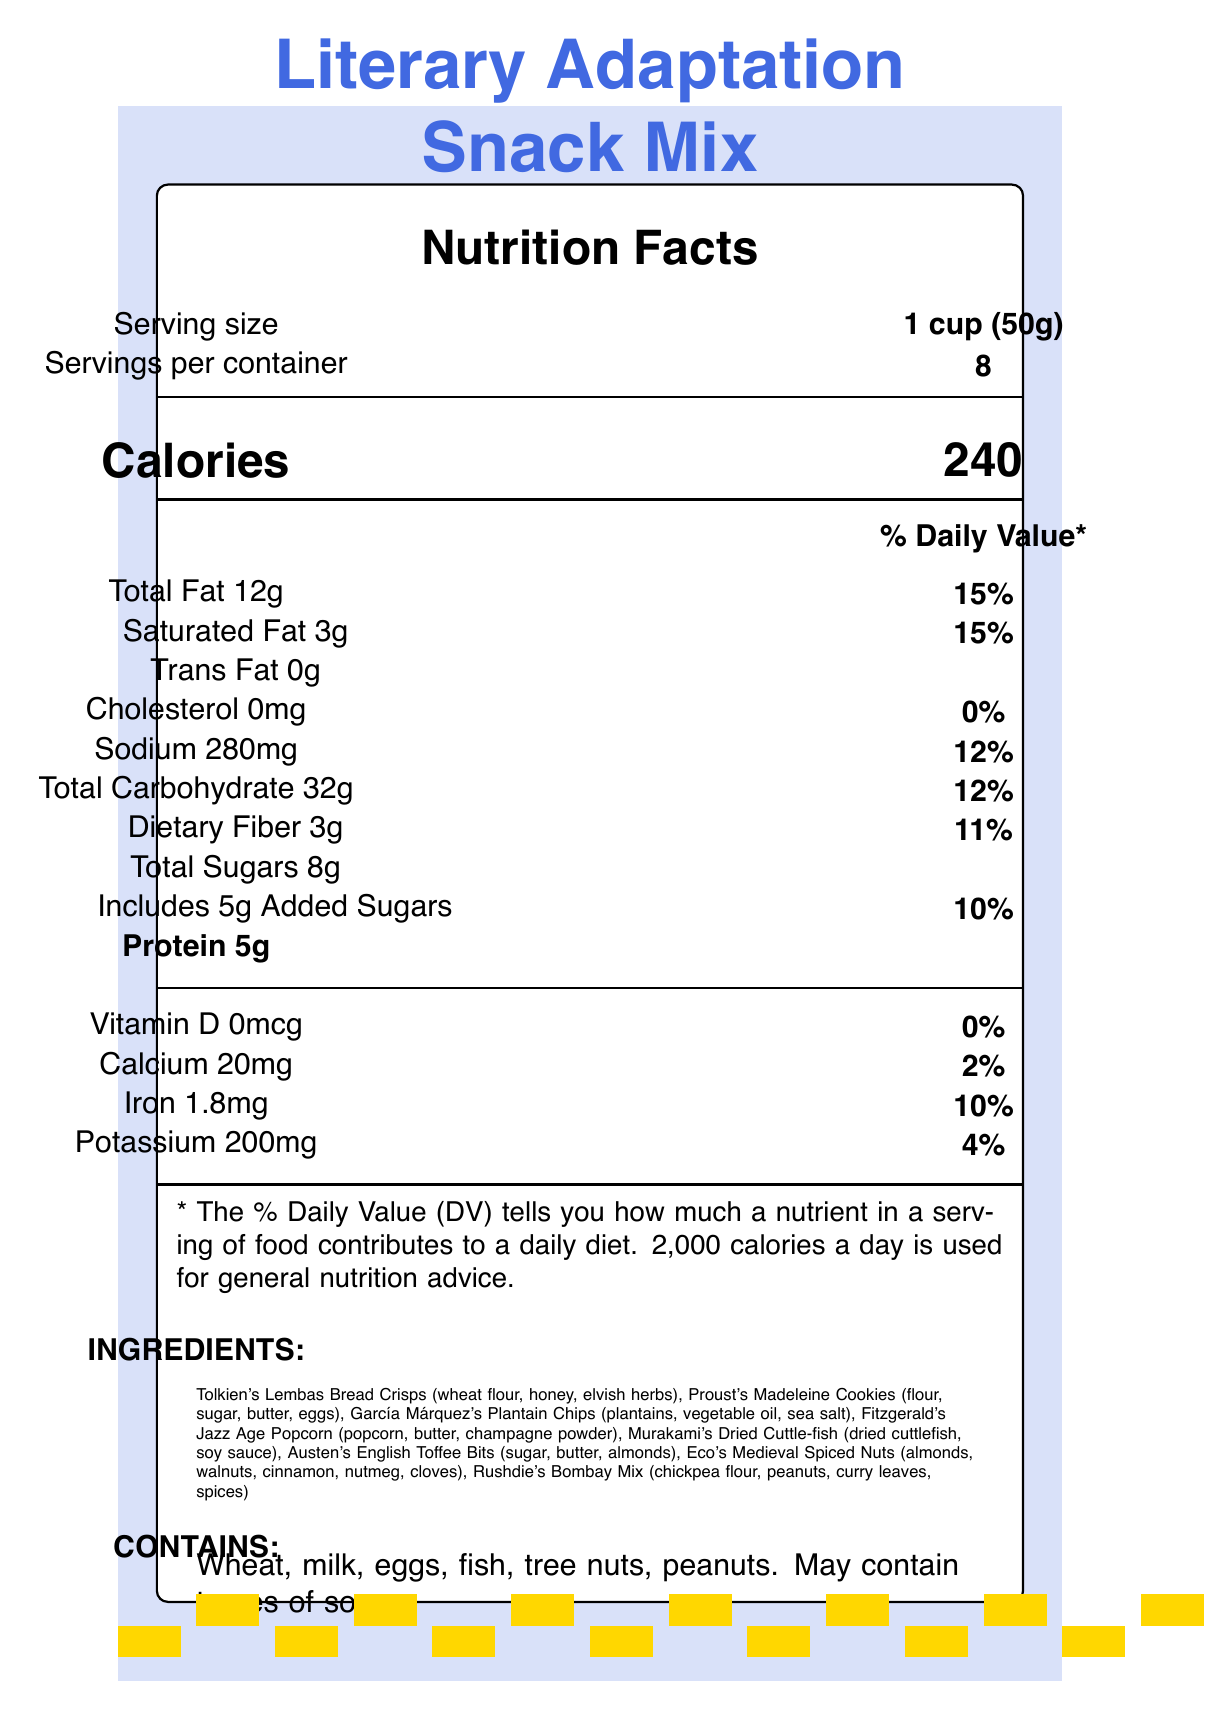what is the serving size for the Literary Adaptation Snack Mix? The serving size is listed as "1 cup (50g)" in the serving size information section.
Answer: 1 cup (50g) how many servings are in the container? The document indicates there are "8" servings per container.
Answer: 8 how many total calories are in one serving of the Literary Adaptation Snack Mix? The number of calories per serving is listed as "240" in the Calories section.
Answer: 240 what are the main ingredients in Tolkien's Lembas Bread Crisps? The ingredients for Tolkien's Lembas Bread Crisps are listed as "wheat flour, honey, elvish herbs" under the ingredients section.
Answer: Wheat flour, honey, elvish herbs what are the total sugars and added sugars in one serving? The document lists total sugars as "8g" and includes "5g" of added sugars per serving.
Answer: Total Sugars: 8g, Added Sugars: 5g what percentage of the daily value of iron does one serving provide? One serving provides "10%" of the daily value of iron as indicated in the Iron section.
Answer: 10% which snack is paired with "The Lord of the Rings trilogy"? The film festival pairings list "Tolkien's Lembas Bread Crisps" as paired with "The Lord of the Rings trilogy."
Answer: Tolkien's Lembas Bread Crisps does the snack mix contain any soy? The allergen information states, "May contain traces of soy."
Answer: May contain traces of soy how much dietary fiber does one serving contain? A. 2g B. 3g C. 5g D. 8g The document lists "3g" of dietary fiber per serving.
Answer: B. 3g which of the following nutrients is not present in the Literary Adaptation Snack Mix? A. Cholesterol B. Sodium C. Protein D. Potassium The document shows "0mg" for cholesterols, indicating it is not present in the snack mix.
Answer: A. Cholesterol is there any vitamin D in the Literary Adaptation Snack Mix? The document lists "0mcg" of vitamin D, indicating there is none in the snack mix.
Answer: No what type of nuts are used in Eco's Medieval Spiced Nuts? The ingredients section lists "almonds, walnuts" for Eco's Medieval Spiced Nuts.
Answer: Almonds and walnuts summarize the main idea of the document. The document includes detailed nutritional facts, a list of ingredients inspired by literary works, allergen details, and curated film pairings to enhance the cinematic experience.
Answer: The document provides nutritional information for the Literary Adaptation Snack Mix, highlights its ingredients sourced from famous literary works, outlines allergen information, and pairs the snacks with their related film adaptations. how much protein does one serving provide? The document lists "5g" of protein per serving.
Answer: 5g how much total fat does the snack contain per serving, and what percentage of the daily value does it represent? The total fat content is "12g," which represents "15%" of the daily value according to the document.
Answer: 12g; 15% which literary adaptation film is paired with García Márquez's Plantain Chips? The film festival pairings section lists García Márquez's Plantain Chips paired with "Love in the Time of Cholera (2007)."
Answer: Love in the Time of Cholera (2007) what is the main theme behind the ingredient selection for the snack mix? The document states this in the literary notes section.
Answer: Each ingredient represents an iconic food item from a famous literary work adapted to film, curated to enhance the cinematic experience of literary adaptations. how is Eco's Medieval Spiced Nuts flavored? The ingredients for Eco's Medieval Spiced Nuts include "cinnamon, nutmeg, cloves."
Answer: With cinnamon, nutmeg, and cloves 